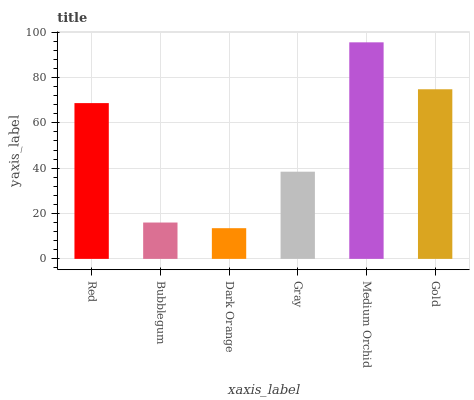Is Dark Orange the minimum?
Answer yes or no. Yes. Is Medium Orchid the maximum?
Answer yes or no. Yes. Is Bubblegum the minimum?
Answer yes or no. No. Is Bubblegum the maximum?
Answer yes or no. No. Is Red greater than Bubblegum?
Answer yes or no. Yes. Is Bubblegum less than Red?
Answer yes or no. Yes. Is Bubblegum greater than Red?
Answer yes or no. No. Is Red less than Bubblegum?
Answer yes or no. No. Is Red the high median?
Answer yes or no. Yes. Is Gray the low median?
Answer yes or no. Yes. Is Medium Orchid the high median?
Answer yes or no. No. Is Medium Orchid the low median?
Answer yes or no. No. 